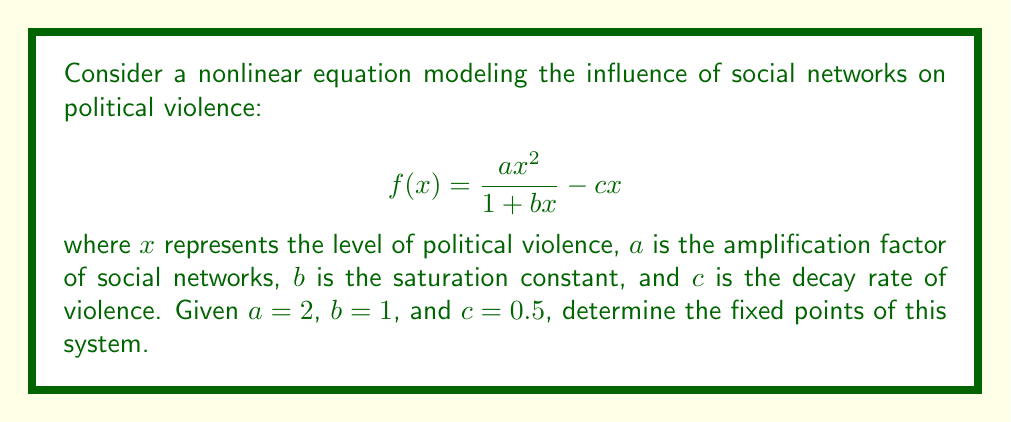Could you help me with this problem? To find the fixed points, we need to solve the equation $f(x) = x$:

1) Set up the equation:
   $$\frac{2x^2}{1 + x} - 0.5x = x$$

2) Multiply both sides by $(1 + x)$:
   $$2x^2 - 0.5x(1 + x) = x(1 + x)$$

3) Expand:
   $$2x^2 - 0.5x - 0.5x^2 = x + x^2$$

4) Rearrange terms:
   $$2x^2 - 0.5x^2 - x^2 - x - 0.5x = 0$$
   $$0.5x^2 - 1.5x = 0$$

5) Factor out $x$:
   $$x(0.5x - 1.5) = 0$$

6) Solve for $x$:
   $x = 0$ or $0.5x - 1.5 = 0$
   $x = 0$ or $x = 3$

7) Verify that these points satisfy the original equation:
   For $x = 0$: $f(0) = 0$
   For $x = 3$: $f(3) = \frac{2(3^2)}{1 + 3} - 0.5(3) = \frac{18}{4} - 1.5 = 3$

Therefore, the fixed points are $x = 0$ and $x = 3$.
Answer: $x = 0$ and $x = 3$ 